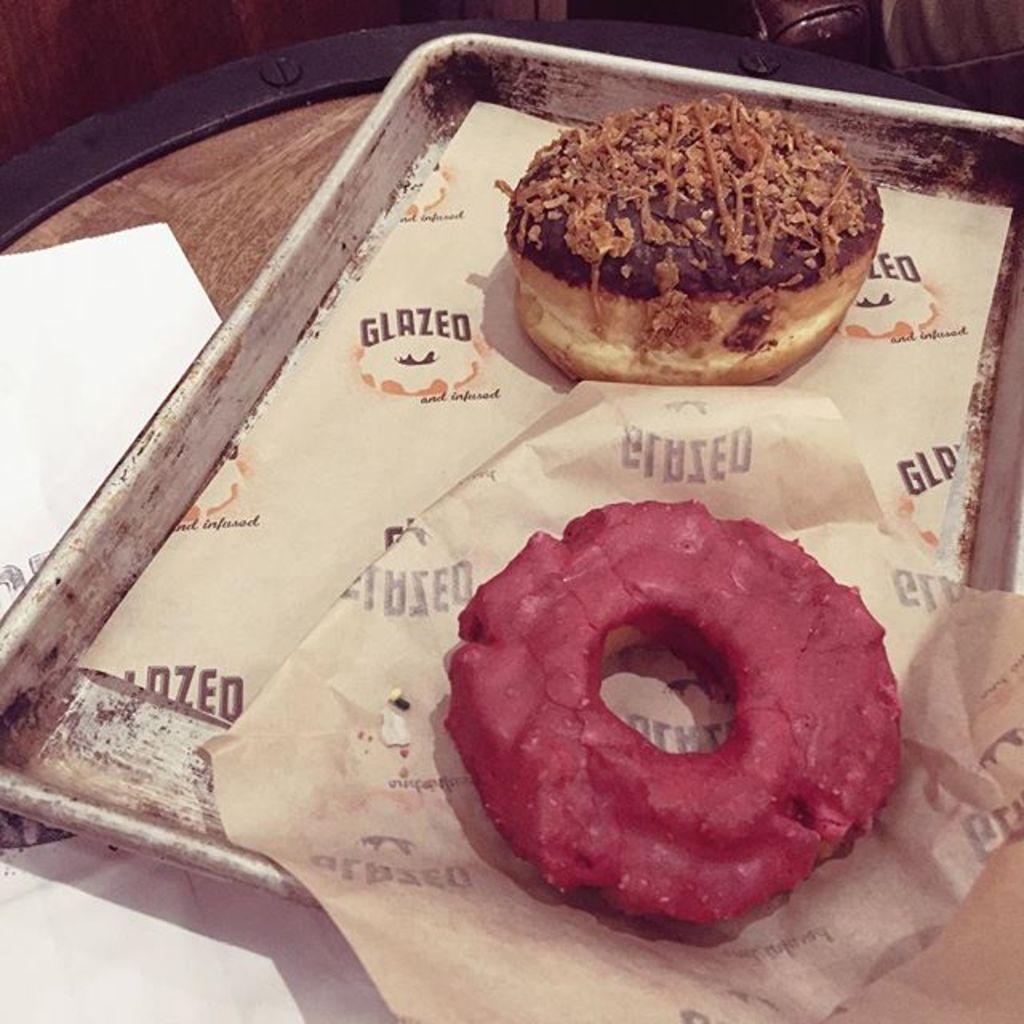What is on the tray in the image? There are food items and papers on a tray in the image. Can you describe the other objects on the wooden surface in the image? Unfortunately, the provided facts do not give any information about the other objects on the wooden surface. How many items are on the tray in the image? There are at least two items on the tray: food items and papers. What type of ball is being used in the competition depicted in the image? There is no competition or ball present in the image; it only shows food items, papers, and other objects on a wooden surface. 